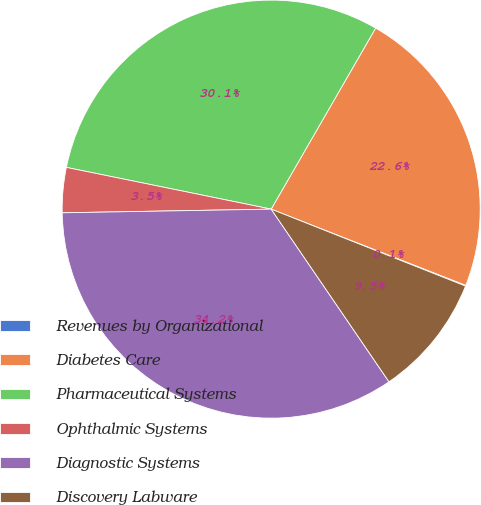<chart> <loc_0><loc_0><loc_500><loc_500><pie_chart><fcel>Revenues by Organizational<fcel>Diabetes Care<fcel>Pharmaceutical Systems<fcel>Ophthalmic Systems<fcel>Diagnostic Systems<fcel>Discovery Labware<nl><fcel>0.06%<fcel>22.61%<fcel>30.13%<fcel>3.48%<fcel>34.25%<fcel>9.47%<nl></chart> 